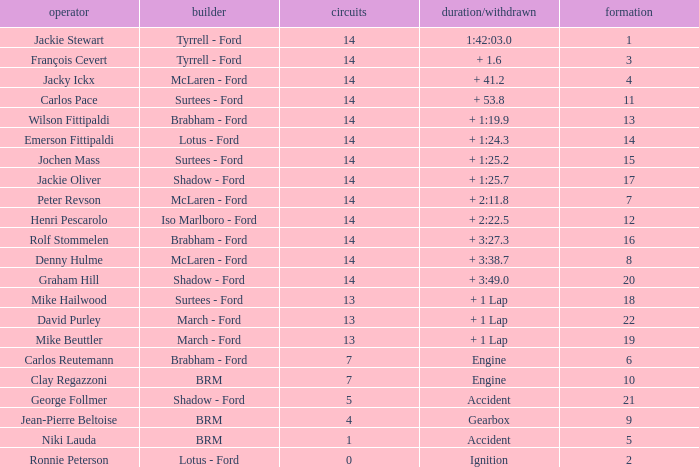What is the low lap total for a grid larger than 16 and has a Time/Retired of + 3:27.3? None. 